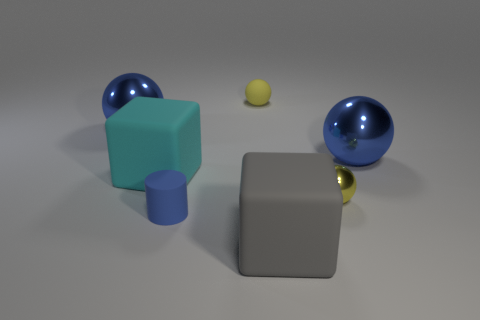Are there any large gray blocks made of the same material as the gray object?
Provide a short and direct response. No. How many red objects are either small things or small cylinders?
Provide a succinct answer. 0. Are there more large spheres in front of the small matte sphere than blue matte things?
Offer a very short reply. Yes. Is the size of the gray object the same as the rubber cylinder?
Give a very brief answer. No. The sphere that is the same material as the small blue object is what color?
Provide a succinct answer. Yellow. There is a tiny rubber thing that is the same color as the small metallic thing; what shape is it?
Offer a very short reply. Sphere. Is the number of yellow rubber things on the right side of the tiny yellow metallic sphere the same as the number of cylinders that are behind the big cyan rubber block?
Provide a short and direct response. Yes. There is a blue object that is right of the big rubber object in front of the small metallic sphere; what is its shape?
Offer a very short reply. Sphere. There is another big object that is the same shape as the big gray object; what is its material?
Provide a short and direct response. Rubber. The rubber sphere that is the same size as the yellow metallic sphere is what color?
Offer a very short reply. Yellow. 